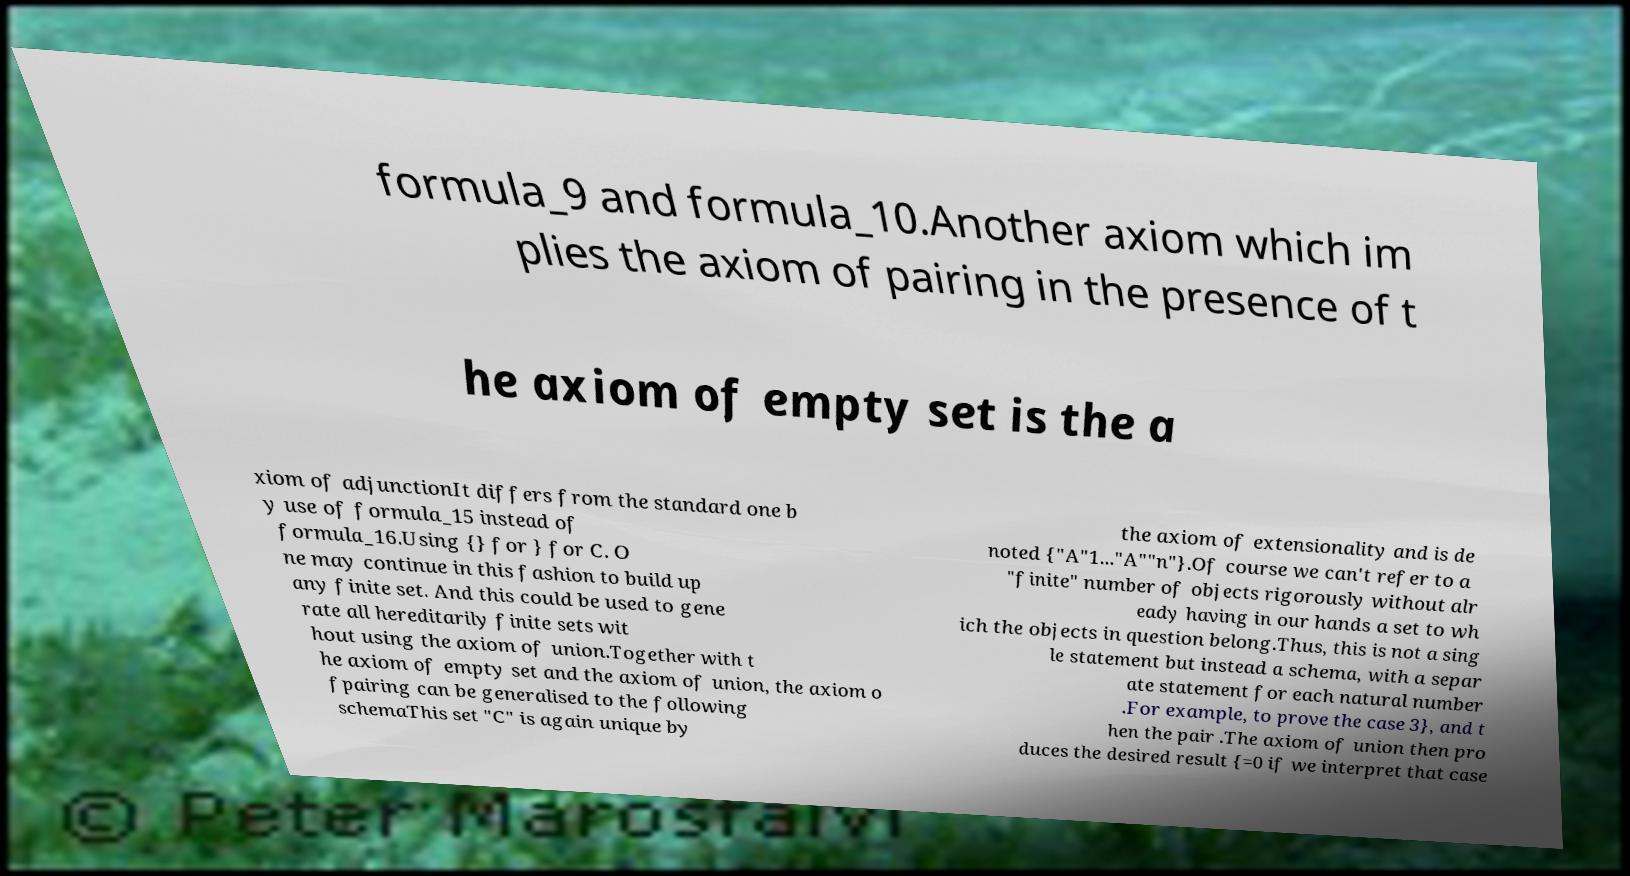There's text embedded in this image that I need extracted. Can you transcribe it verbatim? formula_9 and formula_10.Another axiom which im plies the axiom of pairing in the presence of t he axiom of empty set is the a xiom of adjunctionIt differs from the standard one b y use of formula_15 instead of formula_16.Using {} for } for C. O ne may continue in this fashion to build up any finite set. And this could be used to gene rate all hereditarily finite sets wit hout using the axiom of union.Together with t he axiom of empty set and the axiom of union, the axiom o fpairing can be generalised to the following schemaThis set "C" is again unique by the axiom of extensionality and is de noted {"A"1..."A""n"}.Of course we can't refer to a "finite" number of objects rigorously without alr eady having in our hands a set to wh ich the objects in question belong.Thus, this is not a sing le statement but instead a schema, with a separ ate statement for each natural number .For example, to prove the case 3}, and t hen the pair .The axiom of union then pro duces the desired result {=0 if we interpret that case 